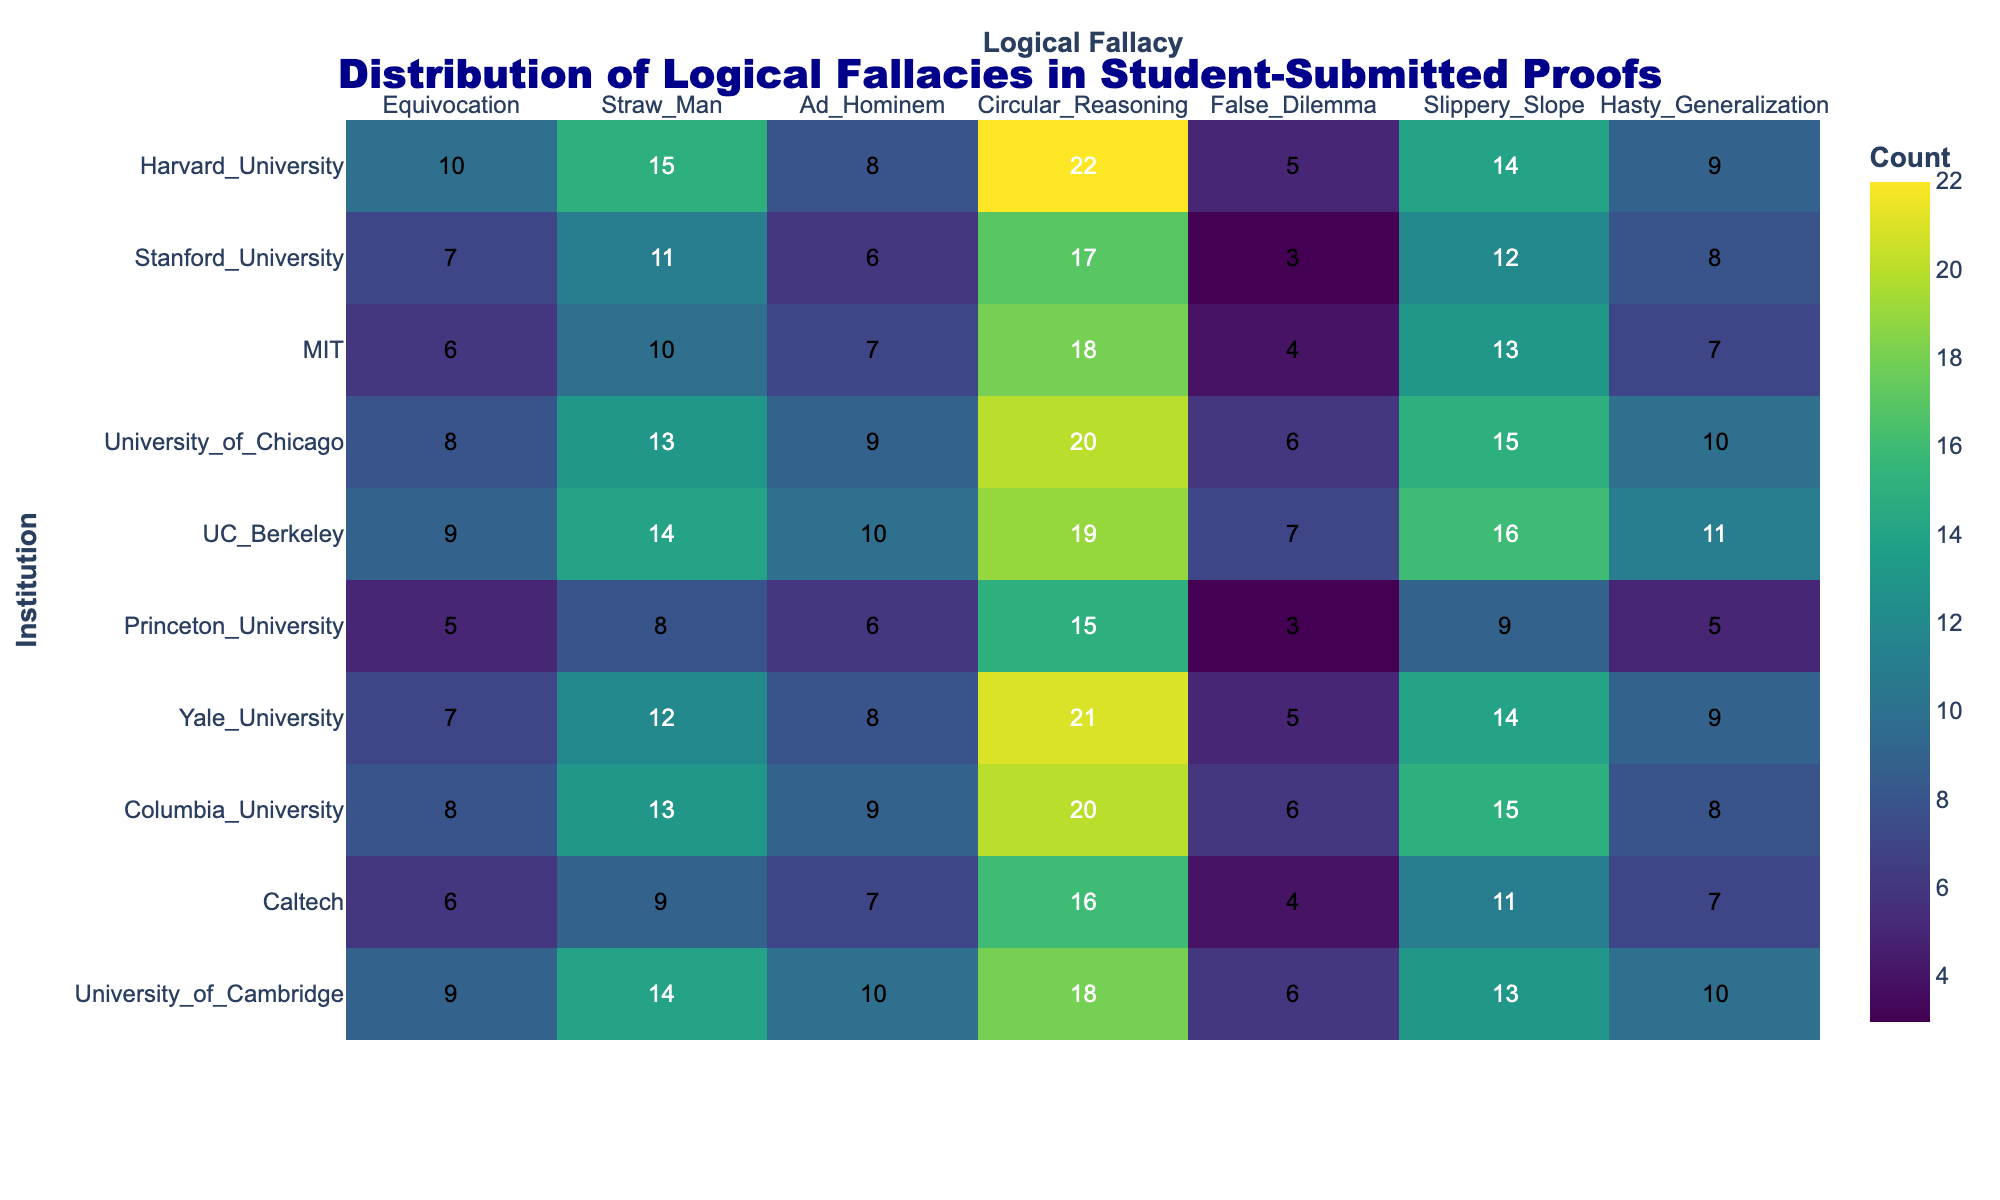What is the title of the heatmap? The title of the heatmap is displayed at the top of the figure in large, dark blue font. It reads "Distribution of Logical Fallacies in Student-Submitted Proofs".
Answer: Distribution of Logical Fallacies in Student-Submitted Proofs Which institution exhibits the highest count of Circular Reasoning fallacies? The heatmap shows the number of each type of fallacy across various institutions. By looking at the column for Circular Reasoning, Harvard University has the highest count, which is 22.
Answer: Harvard University What is the sum of the counts for Straw Man fallacies across all institutions? Add the numbers in the Straw Man column: 15 + 11 + 10 + 13 + 14 + 8 + 12 + 13 + 9 + 14. The sum is 119.
Answer: 119 Which two institutions have the same count for False Dilemma fallacies? Looking at the False Dilemma column, both Stanford University and Princeton University have a count of 3 for this type of fallacy.
Answer: Stanford University and Princeton University What is the average count of Ad Hominem fallacies across all institutions? First, sum up the counts in the Ad Hominem column: 8 + 6 + 7 + 9 + 10 + 6 + 8 + 9 + 7 + 10. The sum is 80. Then, divide by the number of institutions: 80 / 10 = 8.
Answer: 8 Which institution shows the lowest number of Slippery Slope fallacies and what is the count? Look at the Slippery Slope column; Princeton University has the lowest count with 9 total fallacies.
Answer: Princeton University, 9 Compare the counts for Equivocation and Hasty Generalization fallacies at MIT. Which is greater and by how much? For MIT, the count for Equivocation is 6 and Hasty Generalization is 7. The difference is 7 - 6 = 1, so Hasty Generalization is greater by 1.
Answer: Hasty Generalization, 1 What are the counts of logical fallacies at Yale University for both Circular Reasoning and False Dilemma combined? At Yale University, the count for Circular Reasoning is 21 and False Dilemma is 5. Adding these together gives 21 + 5 = 26.
Answer: 26 Which logical fallacy is the most common at University of Chicago? Look at the row for University of Chicago and identify the highest count: Circular Reasoning has a count of 20, which is the highest number among the fallacies.
Answer: Circular Reasoning What is the total number of Hasty Generalization fallacies reported at institutions starting with the letter 'U'? Summing up the Hasty Generalization counts for University of Chicago (10), UC Berkeley (11), University of Cambridge (10), the total is 10 + 11 + 10 = 31.
Answer: 31 